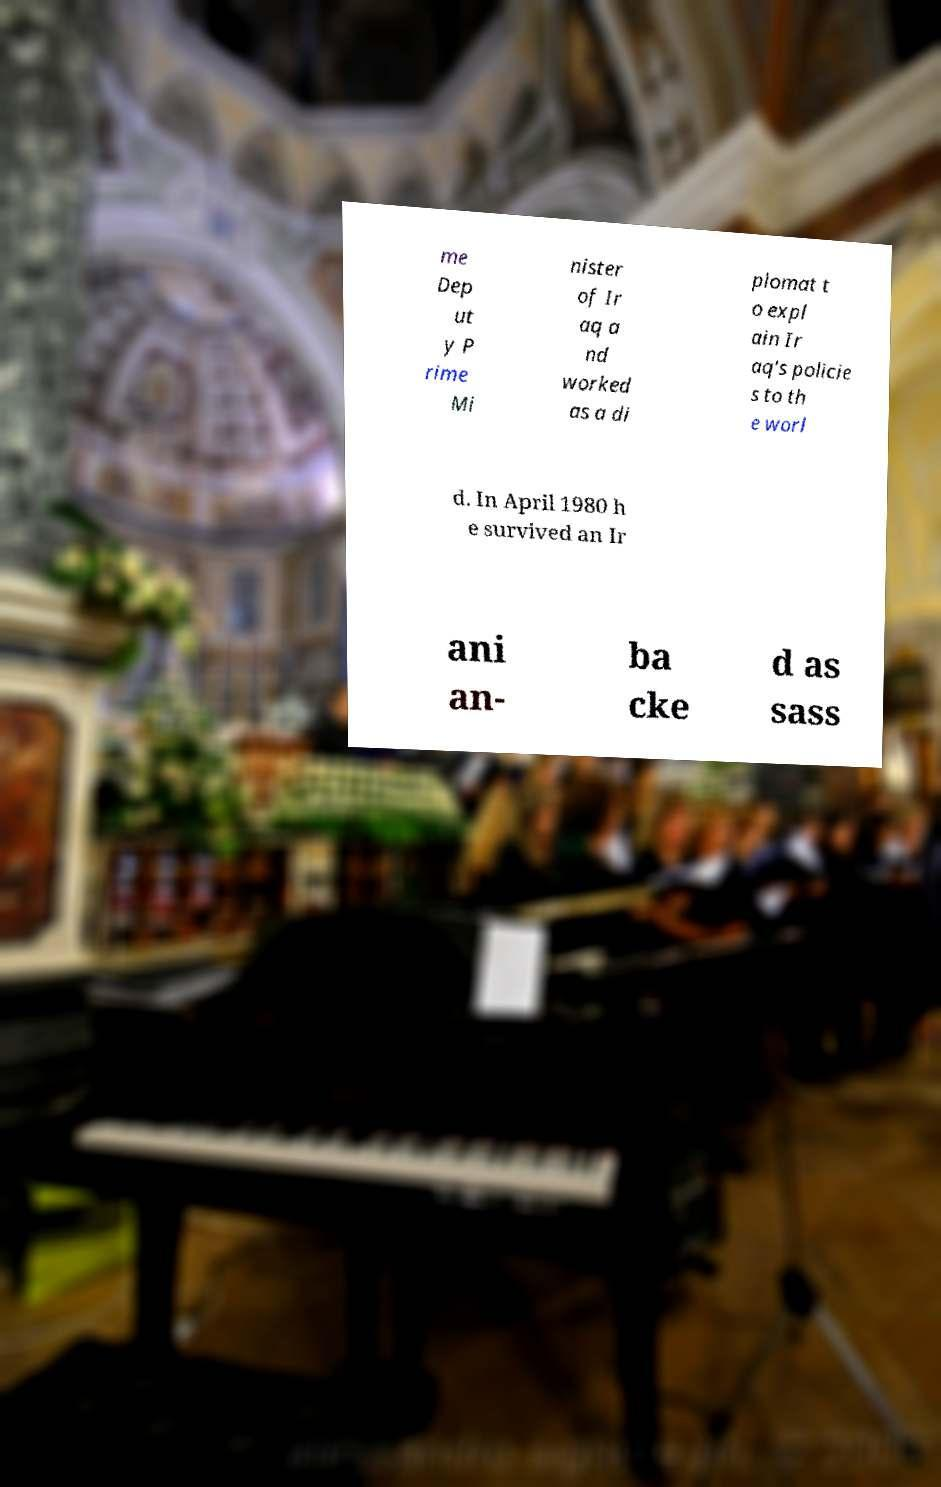Could you extract and type out the text from this image? me Dep ut y P rime Mi nister of Ir aq a nd worked as a di plomat t o expl ain Ir aq's policie s to th e worl d. In April 1980 h e survived an Ir ani an- ba cke d as sass 